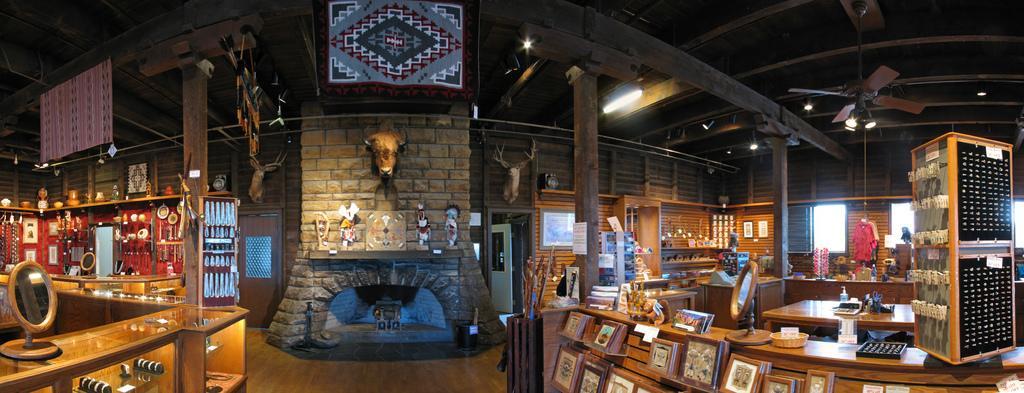Please provide a concise description of this image. In this picture we can see the view of artificial jewelry shop. In the center we can see the fireplace with two deer statue. In the front there is a wooden table with photo frames and hanging earrings. On the left side we can see the table with mirror and jewelry in the box. On the top we can see the wooden ceiling with fans and lights. 